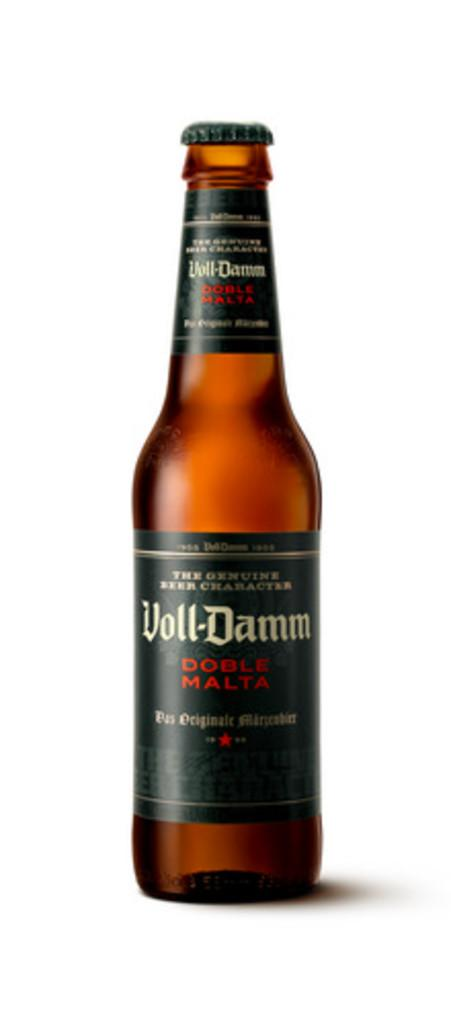<image>
Write a terse but informative summary of the picture. A bottle of Voll-Damm with dark colored label attached to it. 